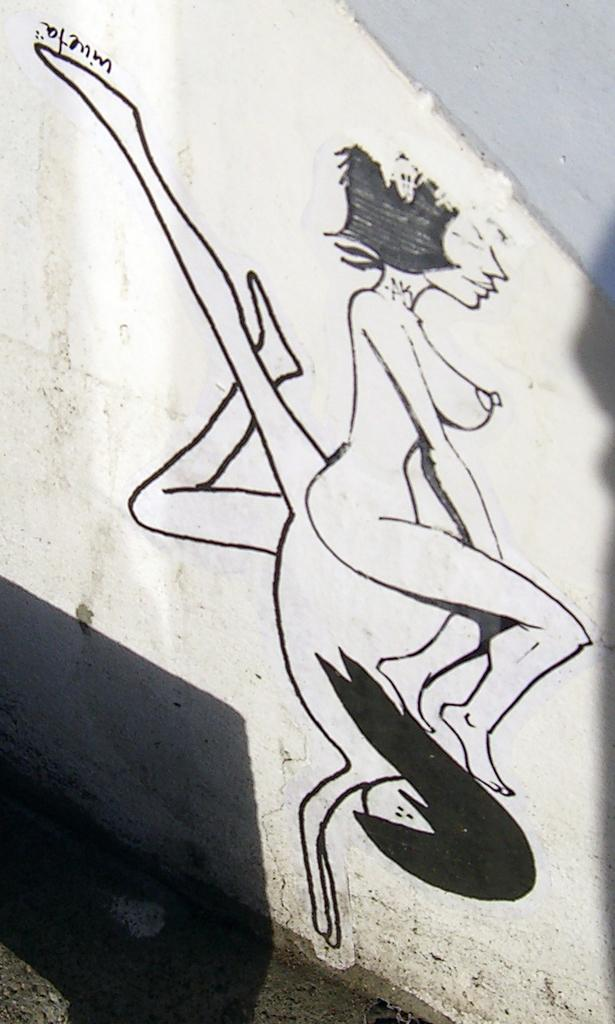What can be seen on the wall in the image? There is a drawing of two people on the wall. What else is present on the wall besides the drawing? There is text written on the wall. What is visible in the background of the image? There is a road visible in the image. What type of skirt is being distributed in the image? There is no skirt present in the image, nor is there any indication of distribution taking place. 